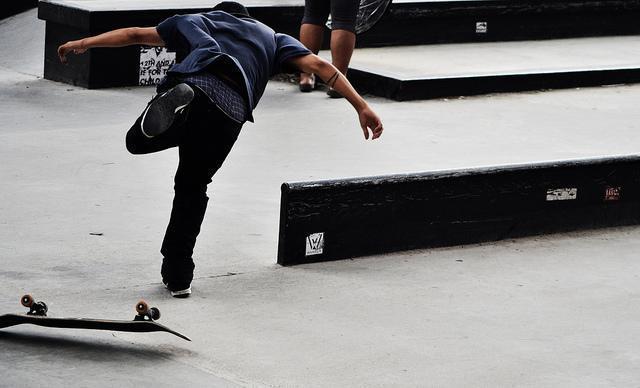How he is going to get hurt?
Select the accurate answer and provide justification: `Answer: choice
Rationale: srationale.`
Options: Flying, beaten, shot, falling. Answer: falling.
Rationale: It looks like it may happen any second now.  i think it's safe to say he doesn't know how to fly.  no one is in view that is going to beat him up or shoot him. 